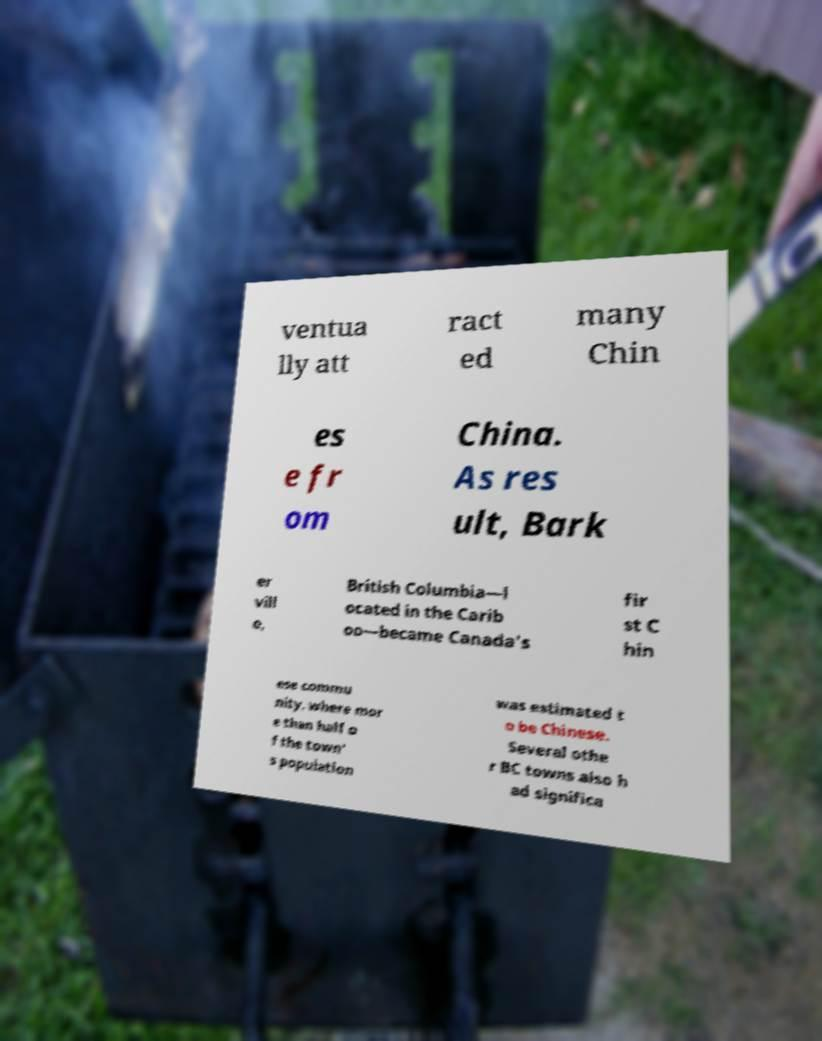I need the written content from this picture converted into text. Can you do that? ventua lly att ract ed many Chin es e fr om China. As res ult, Bark er vill e, British Columbia—l ocated in the Carib oo—became Canada's fir st C hin ese commu nity, where mor e than half o f the town' s population was estimated t o be Chinese. Several othe r BC towns also h ad significa 